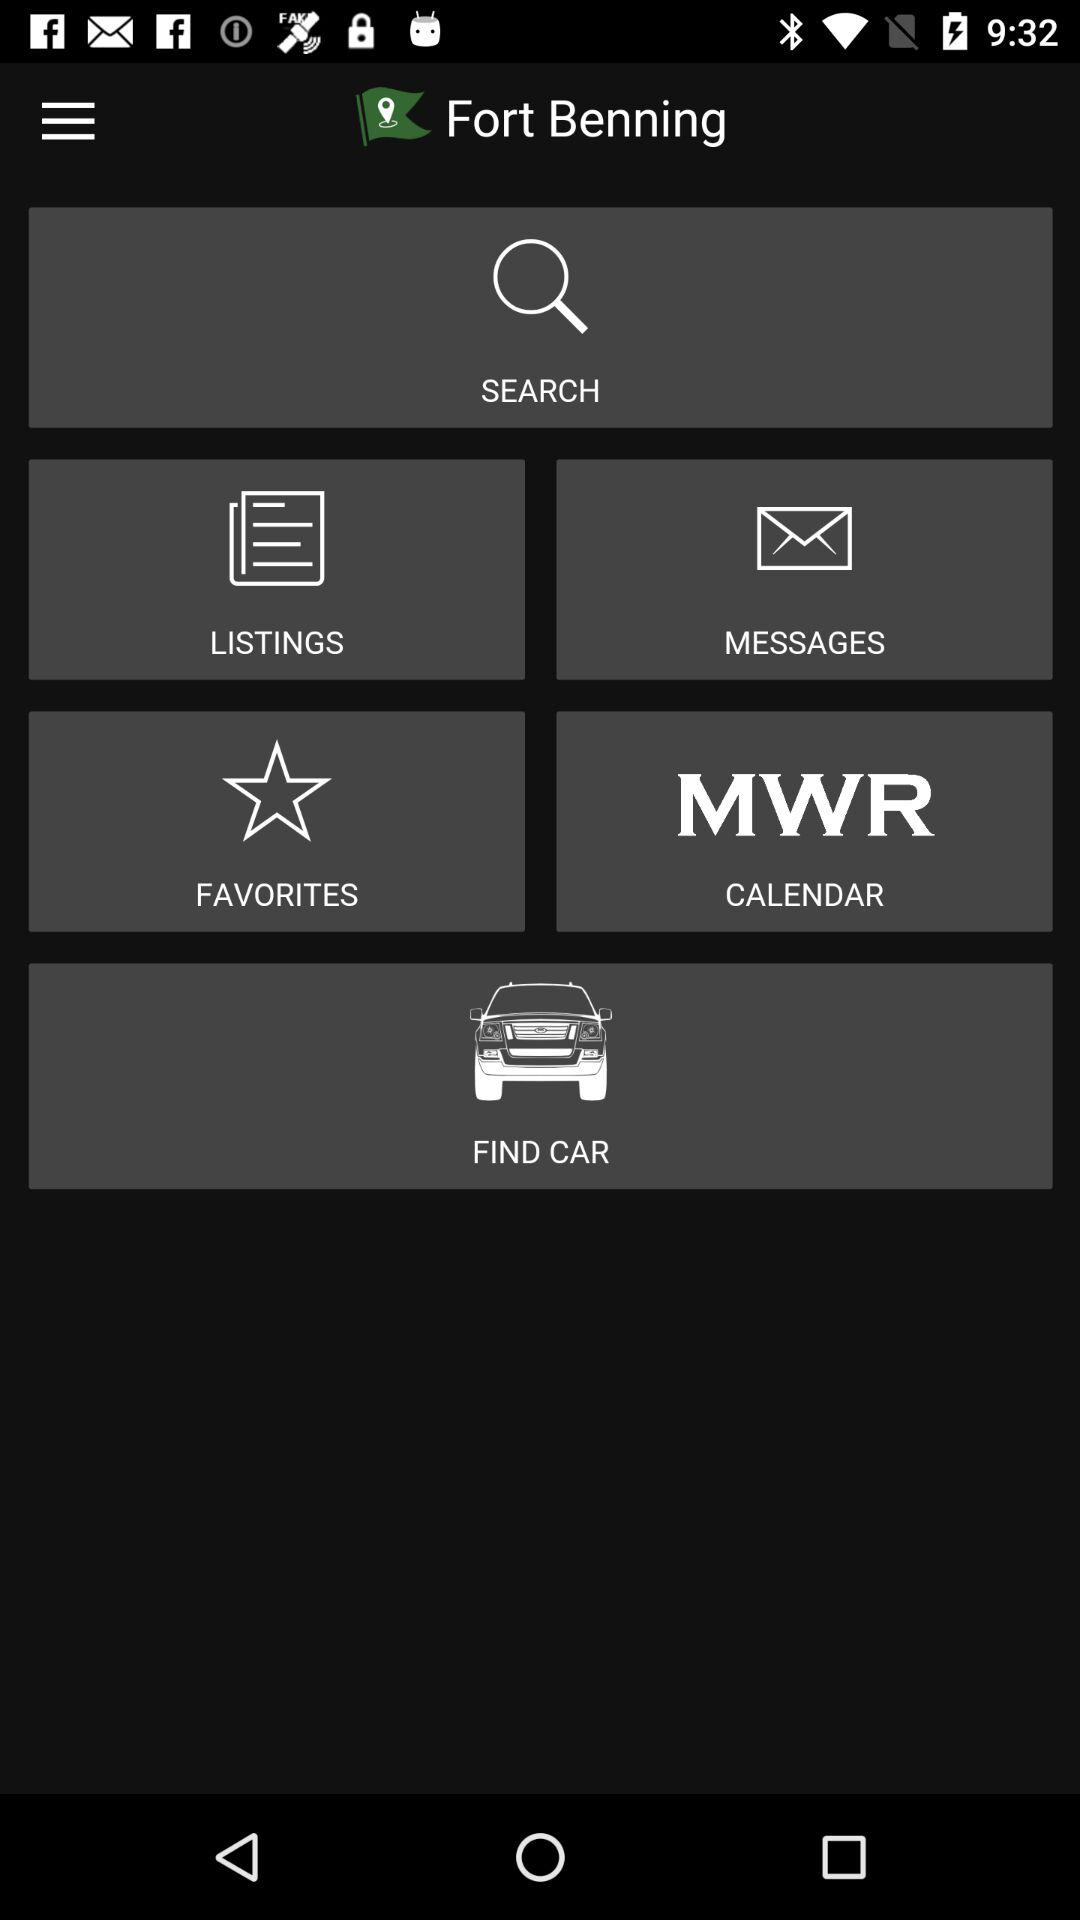What is the name of the application? The name of the application is "Fort Benning". 